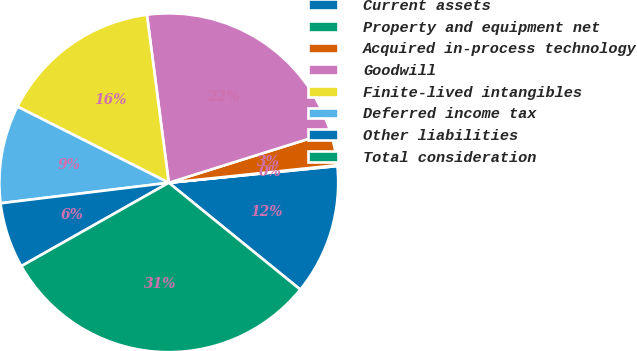Convert chart to OTSL. <chart><loc_0><loc_0><loc_500><loc_500><pie_chart><fcel>Current assets<fcel>Property and equipment net<fcel>Acquired in-process technology<fcel>Goodwill<fcel>Finite-lived intangibles<fcel>Deferred income tax<fcel>Other liabilities<fcel>Total consideration<nl><fcel>12.43%<fcel>0.09%<fcel>3.18%<fcel>22.22%<fcel>15.52%<fcel>9.35%<fcel>6.26%<fcel>30.95%<nl></chart> 